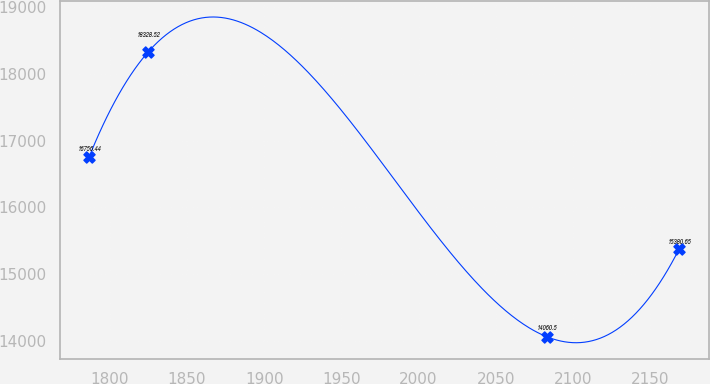Convert chart to OTSL. <chart><loc_0><loc_0><loc_500><loc_500><line_chart><ecel><fcel>Unnamed: 1<nl><fcel>1786.55<fcel>16756.4<nl><fcel>1824.79<fcel>18328.5<nl><fcel>2083.08<fcel>14060.5<nl><fcel>2168.96<fcel>15380.6<nl></chart> 